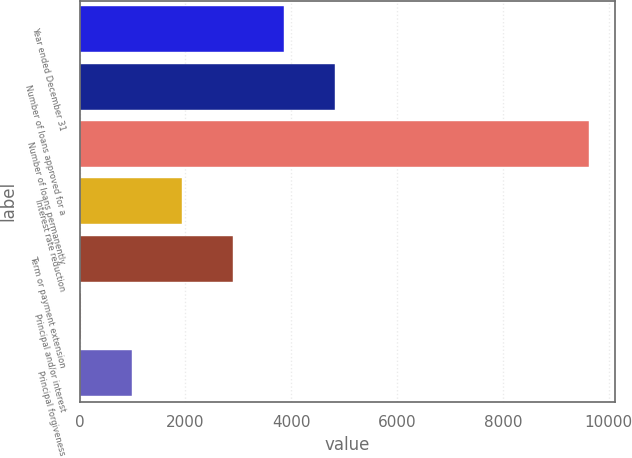<chart> <loc_0><loc_0><loc_500><loc_500><bar_chart><fcel>Year ended December 31<fcel>Number of loans approved for a<fcel>Number of loans permanently<fcel>Interest rate reduction<fcel>Term or payment extension<fcel>Principal and/or interest<fcel>Principal forgiveness<nl><fcel>3863.6<fcel>4825<fcel>9632<fcel>1940.8<fcel>2902.2<fcel>18<fcel>979.4<nl></chart> 